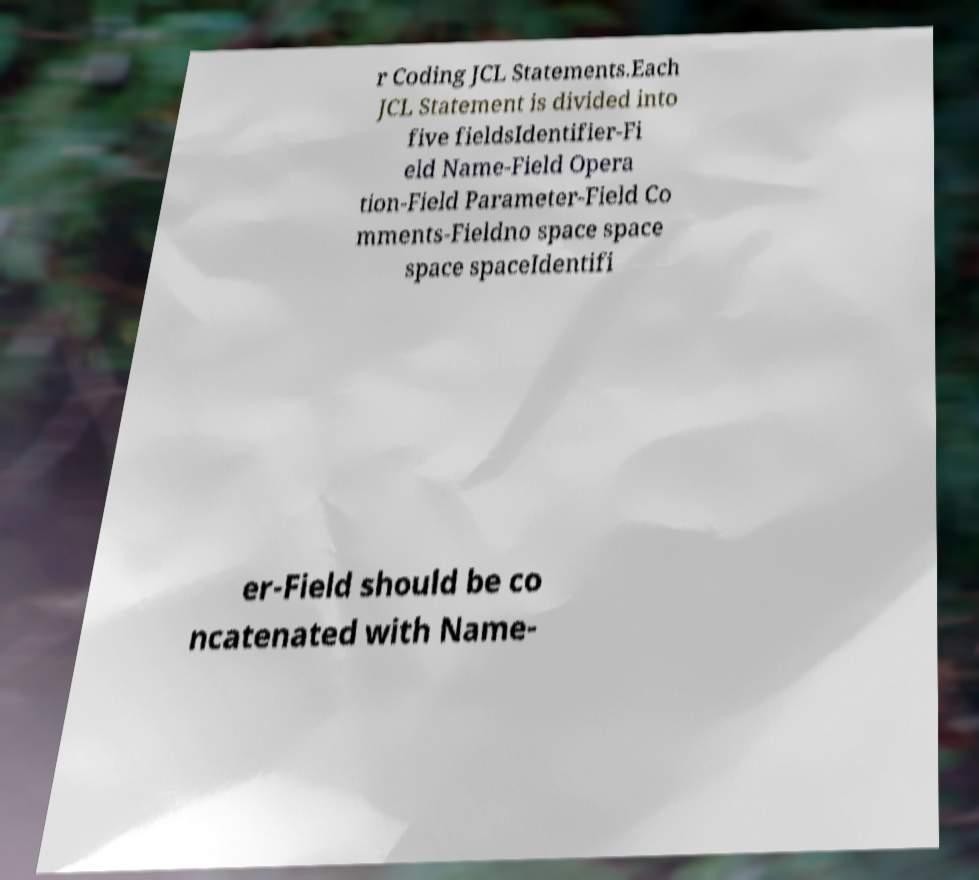For documentation purposes, I need the text within this image transcribed. Could you provide that? r Coding JCL Statements.Each JCL Statement is divided into five fieldsIdentifier-Fi eld Name-Field Opera tion-Field Parameter-Field Co mments-Fieldno space space space spaceIdentifi er-Field should be co ncatenated with Name- 